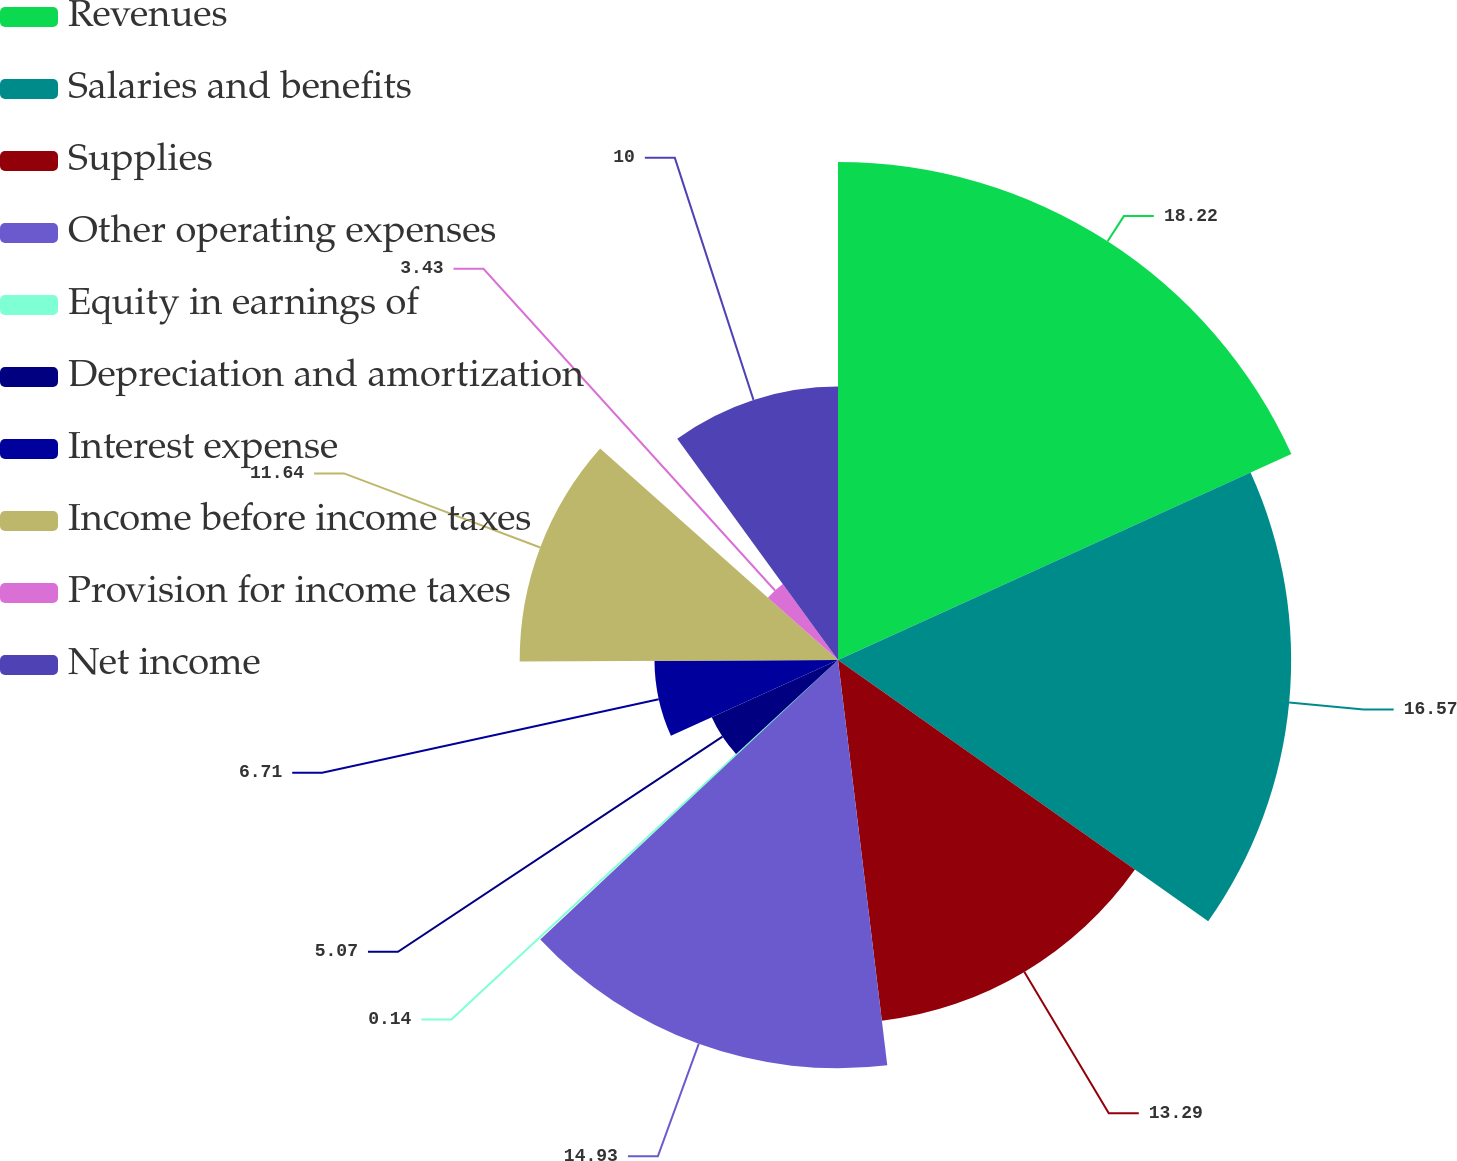<chart> <loc_0><loc_0><loc_500><loc_500><pie_chart><fcel>Revenues<fcel>Salaries and benefits<fcel>Supplies<fcel>Other operating expenses<fcel>Equity in earnings of<fcel>Depreciation and amortization<fcel>Interest expense<fcel>Income before income taxes<fcel>Provision for income taxes<fcel>Net income<nl><fcel>18.21%<fcel>16.57%<fcel>13.29%<fcel>14.93%<fcel>0.14%<fcel>5.07%<fcel>6.71%<fcel>11.64%<fcel>3.43%<fcel>10.0%<nl></chart> 